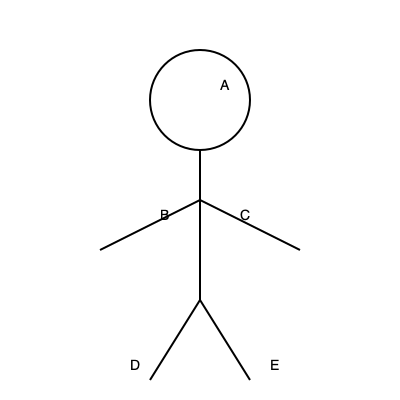As a former football player who played under Coach Rondeau at Pace University, identify which muscle group labeled in the diagram is most crucial for a quarterback's throwing motion. To answer this question, let's analyze each labeled muscle group and its role in a quarterback's throwing motion:

1. A: This represents the deltoid muscles, which are important for shoulder movement but not the primary muscle for throwing.

2. B: This area represents the pectoralis major, which is crucial for the initial push of the throwing motion.

3. C: This depicts the latissimus dorsi, which helps in the follow-through of the throw but isn't the primary muscle for the initial force.

4. D and E: These represent the quadriceps and hamstrings, respectively. While important for overall stability, they're not directly involved in the throwing motion of the upper body.

The most crucial muscle group for a quarterback's throwing motion is the pectoralis major (B). This large chest muscle is primarily responsible for the powerful forward motion of the arm during a throw. It's the main driver of the initial push that generates the force needed to propel the football.

Coach Rondeau would have emphasized the importance of developing and utilizing the pectoral muscles for an effective throwing technique. As a former player, you would have spent considerable time strengthening this muscle group to improve your passing game.
Answer: Pectoralis major (B) 